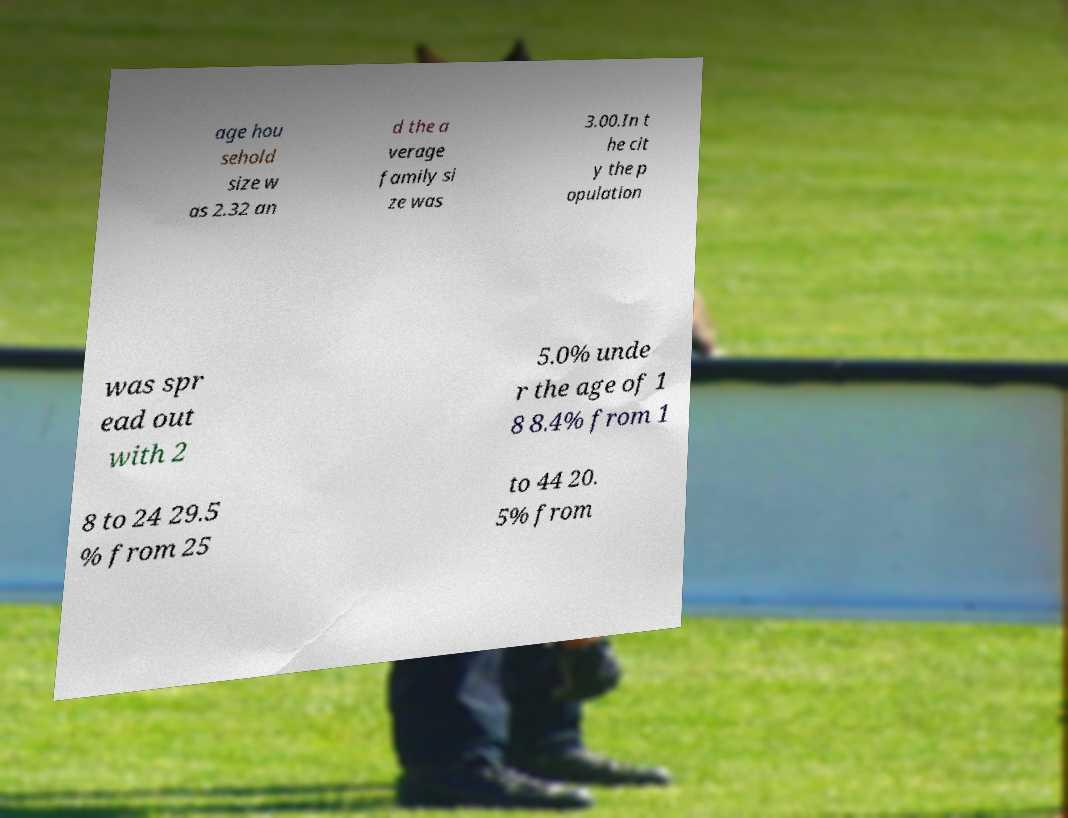There's text embedded in this image that I need extracted. Can you transcribe it verbatim? age hou sehold size w as 2.32 an d the a verage family si ze was 3.00.In t he cit y the p opulation was spr ead out with 2 5.0% unde r the age of 1 8 8.4% from 1 8 to 24 29.5 % from 25 to 44 20. 5% from 